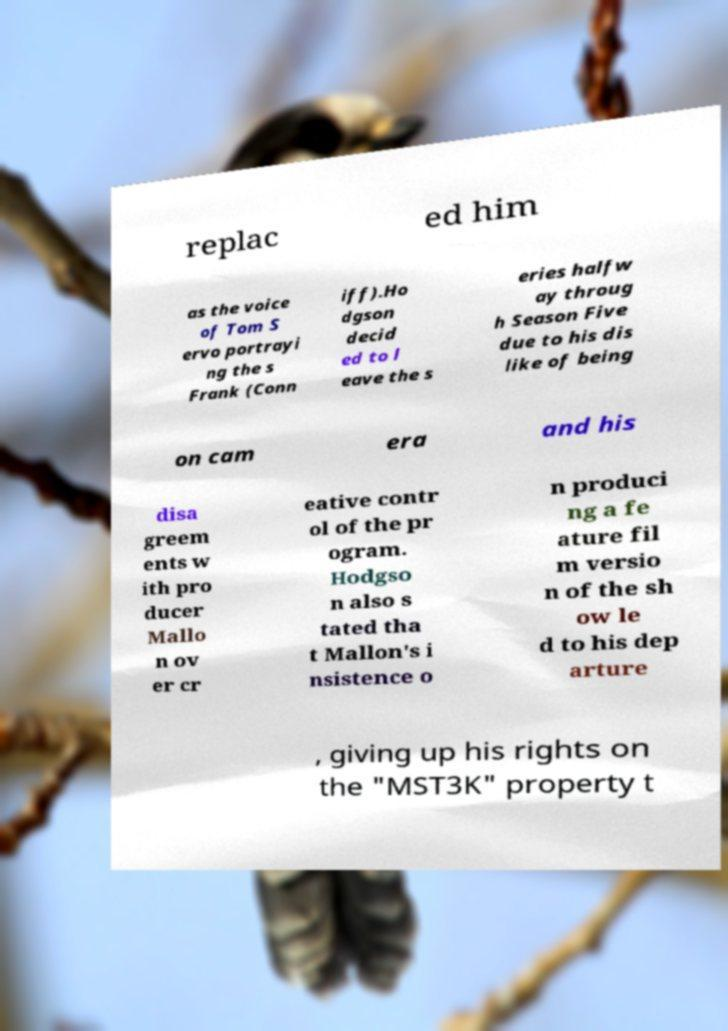What messages or text are displayed in this image? I need them in a readable, typed format. replac ed him as the voice of Tom S ervo portrayi ng the s Frank (Conn iff).Ho dgson decid ed to l eave the s eries halfw ay throug h Season Five due to his dis like of being on cam era and his disa greem ents w ith pro ducer Mallo n ov er cr eative contr ol of the pr ogram. Hodgso n also s tated tha t Mallon's i nsistence o n produci ng a fe ature fil m versio n of the sh ow le d to his dep arture , giving up his rights on the "MST3K" property t 